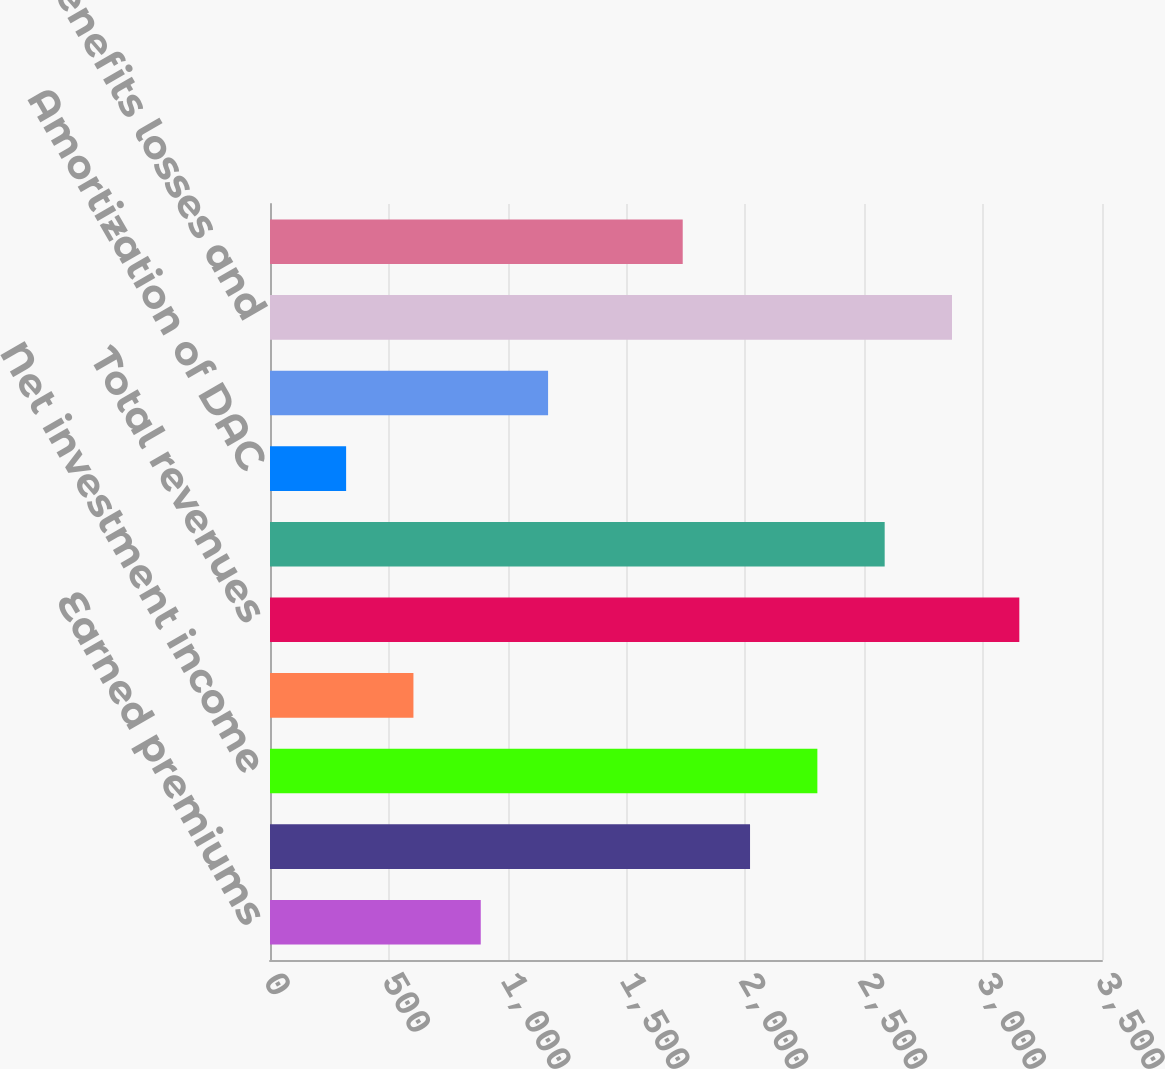Convert chart. <chart><loc_0><loc_0><loc_500><loc_500><bar_chart><fcel>Earned premiums<fcel>Fee income and other<fcel>Net investment income<fcel>Net realized capital losses<fcel>Total revenues<fcel>Benefits losses and loss<fcel>Amortization of DAC<fcel>Insurance operating costs and<fcel>Total benefits losses and<fcel>Income before income taxes<nl><fcel>886.6<fcel>2019.4<fcel>2302.6<fcel>603.4<fcel>3152.2<fcel>2585.8<fcel>320.2<fcel>1169.8<fcel>2869<fcel>1736.2<nl></chart> 